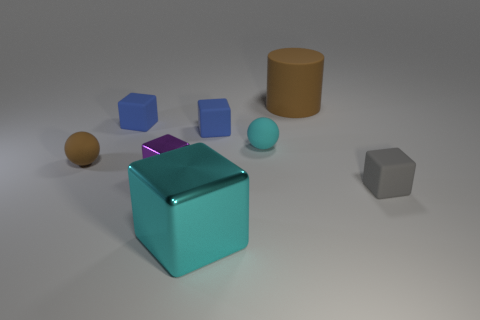What number of big things are blue rubber cylinders or matte cylinders?
Make the answer very short. 1. Does the big shiny thing have the same shape as the small purple metallic thing?
Keep it short and to the point. Yes. What number of spheres are left of the tiny shiny object and behind the tiny brown object?
Your response must be concise. 0. Are there any other things of the same color as the small metallic block?
Give a very brief answer. No. The thing that is the same material as the tiny purple block is what shape?
Provide a succinct answer. Cube. Is the size of the cyan rubber thing the same as the cylinder?
Your answer should be very brief. No. Is the cyan thing that is in front of the tiny brown matte sphere made of the same material as the brown cylinder?
Offer a terse response. No. What number of metallic objects are behind the sphere that is to the left of the metallic block behind the big cyan block?
Provide a succinct answer. 0. Does the brown object in front of the brown cylinder have the same shape as the cyan rubber object?
Provide a succinct answer. Yes. What number of objects are big metallic blocks or rubber cubes in front of the tiny purple metallic block?
Your answer should be compact. 2. 